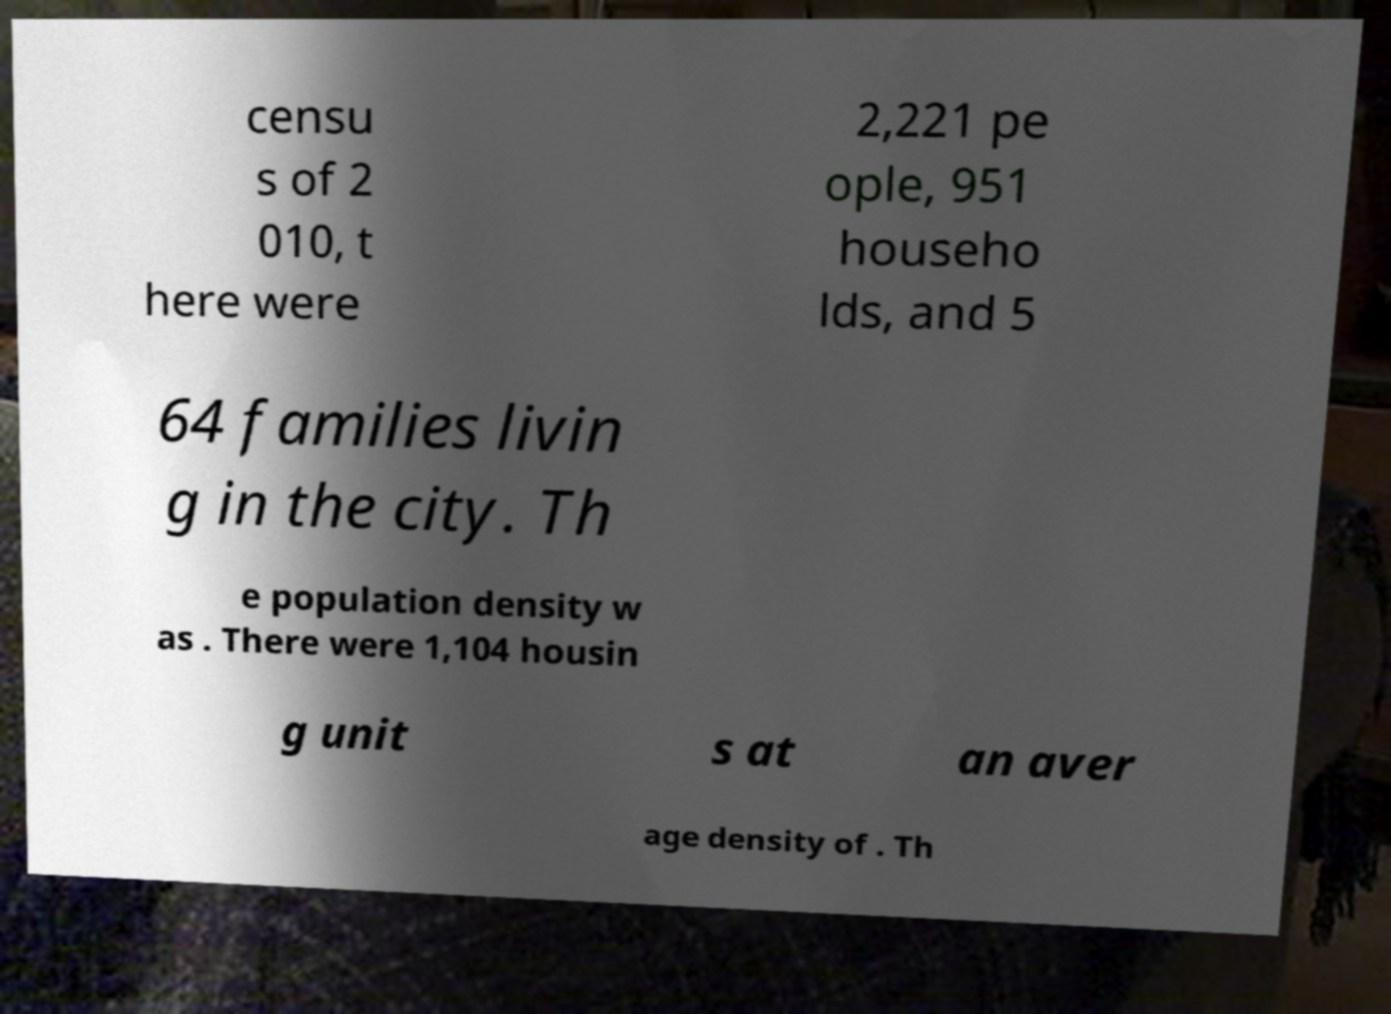What messages or text are displayed in this image? I need them in a readable, typed format. censu s of 2 010, t here were 2,221 pe ople, 951 househo lds, and 5 64 families livin g in the city. Th e population density w as . There were 1,104 housin g unit s at an aver age density of . Th 